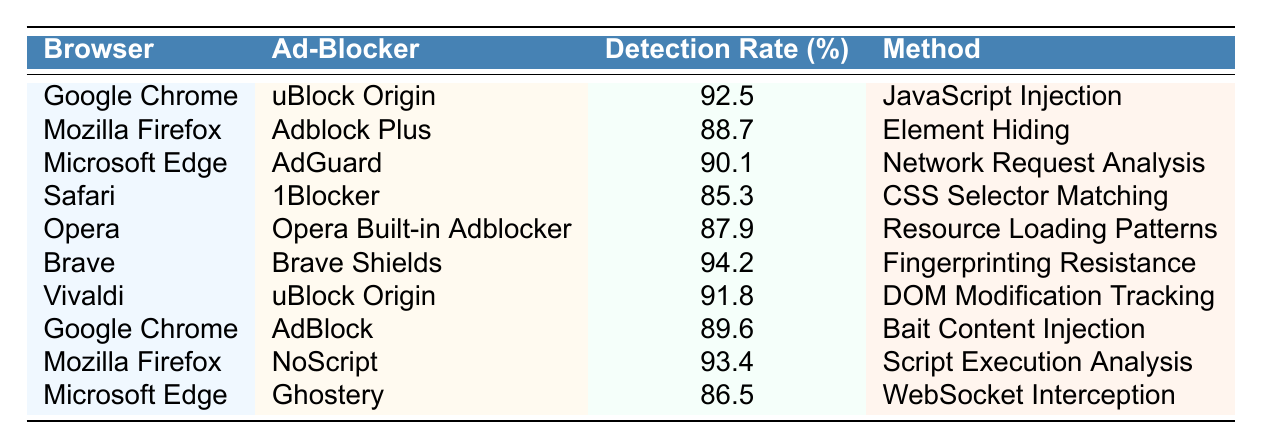What is the highest detection rate among ad-blockers in the table? The detection rates listed are: 92.5, 88.7, 90.1, 85.3, 87.9, 94.2, 91.8, 89.6, 93.4, and 86.5. The highest number is 94.2, which corresponds to Brave Shields in the Brave browser.
Answer: 94.2 Which ad-blocker has a lower detection rate: AdGuard or Adblock Plus? AdGuard has a detection rate of 90.1%, while Adblock Plus has 88.7%. Since 88.7% is lower than 90.1%, Adblock Plus has the lower detection rate.
Answer: Adblock Plus What method does Safari's ad-blocker use? According to the table, 1Blocker, which is the ad-blocker for Safari, uses the method of CSS Selector Matching.
Answer: CSS Selector Matching On which browser does NoScript operate, and what is its detection rate? NoScript operates on Mozilla Firefox, where it has a detection rate of 93.4%.
Answer: Mozilla Firefox, 93.4 What is the average detection rate for the ad-blockers listed in Google Chrome? The detection rates for Google Chrome's ad-blockers (uBlock Origin and AdBlock) are 92.5% and 89.6%. The sum is 92.5 + 89.6 = 182.1. There are two data points, so the average is 182.1 / 2 = 91.05%.
Answer: 91.05 Is the detection rate of Ghostery higher than that of 1Blocker? Ghostery's detection rate is 86.5%, while 1Blocker has a detection rate of 85.3%. Since 86.5% is greater than 85.3%, the answer is yes.
Answer: Yes Which browser has the lowest detection rate and what is the percentage? The detection rates listed include 85.3%, 86.5%, 87.9%, ..., with the lowest being 85.3%, which corresponds to 1Blocker in the Safari browser.
Answer: Safari, 85.3 What percentage difference exists between Brave Shields and uBlock Origin in Vivaldi? Brave Shields has a detection rate of 94.2%, while uBlock Origin in Vivaldi has 91.8%. The difference is 94.2 - 91.8 = 2.4%.
Answer: 2.4 How many ad-blockers listed have a detection rate of 90% or higher? The ad-blockers with detection rates of 90% or higher are uBlock Origin (92.5%), AdGuard (90.1%), Brave Shields (94.2%), uBlock Origin in Vivaldi (91.8%), and NoScript (93.4%). Thus, there are five.
Answer: Five Which detection method is associated with the lowest detection rate and what is that rate? The lowest detection rate is 85.3%, associated with the CSS Selector Matching method used by 1Blocker in Safari.
Answer: CSS Selector Matching, 85.3 